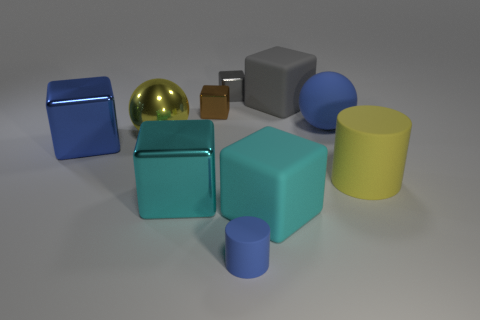Subtract all gray cubes. How many cubes are left? 4 Subtract all small brown cubes. How many cubes are left? 5 Subtract all brown blocks. Subtract all gray balls. How many blocks are left? 5 Subtract all balls. How many objects are left? 8 Add 6 blue cubes. How many blue cubes are left? 7 Add 2 gray balls. How many gray balls exist? 2 Subtract 1 gray cubes. How many objects are left? 9 Subtract all big yellow metallic spheres. Subtract all big metallic things. How many objects are left? 6 